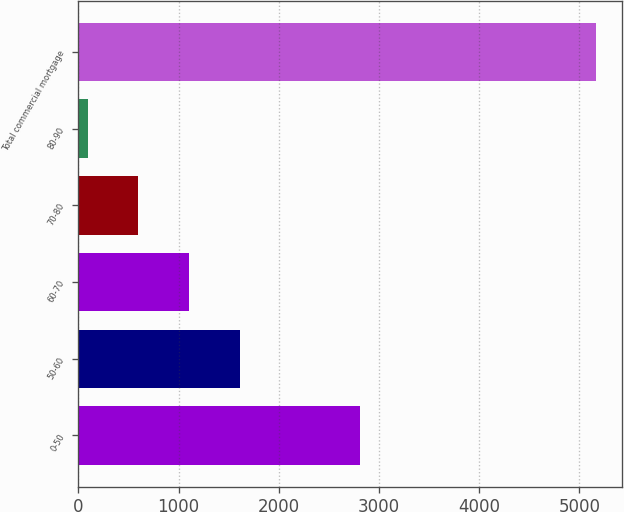Convert chart to OTSL. <chart><loc_0><loc_0><loc_500><loc_500><bar_chart><fcel>0-50<fcel>50-60<fcel>60-70<fcel>70-80<fcel>80-90<fcel>Total commercial mortgage<nl><fcel>2813<fcel>1615.5<fcel>1108<fcel>600.5<fcel>93<fcel>5168<nl></chart> 